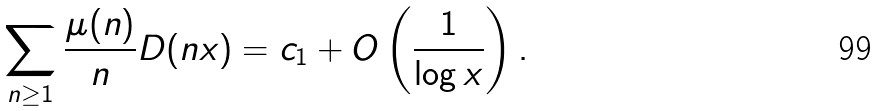Convert formula to latex. <formula><loc_0><loc_0><loc_500><loc_500>\sum _ { n \geq 1 } \frac { \mu ( n ) } { n } D ( n x ) = c _ { 1 } + O \left ( \frac { 1 } { \log x } \right ) .</formula> 